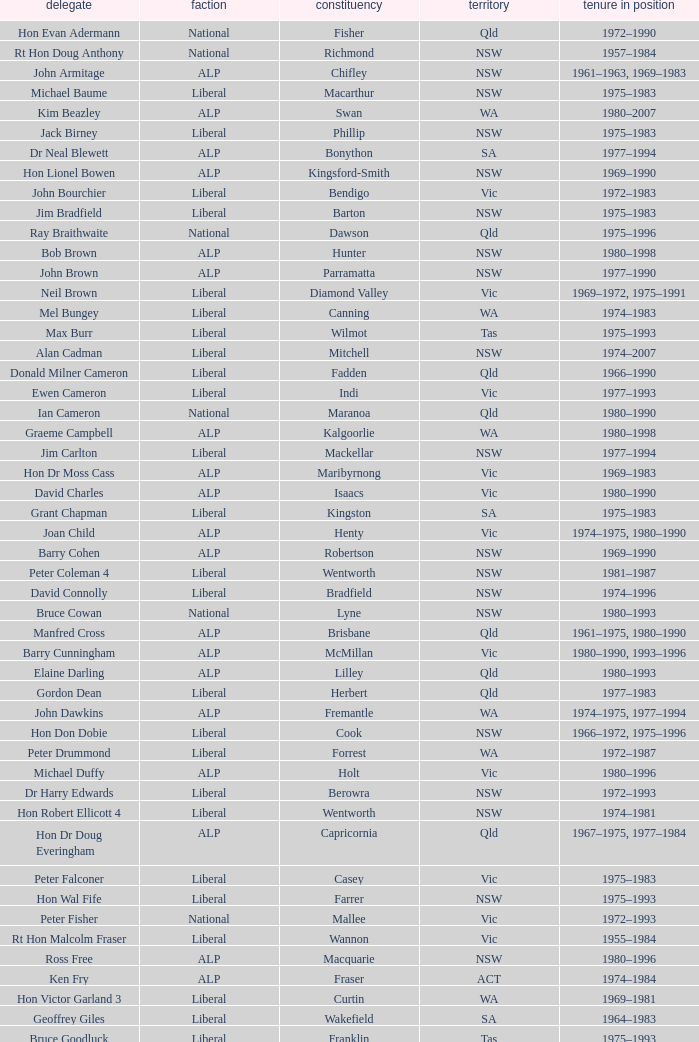What party is Mick Young a member of? ALP. 